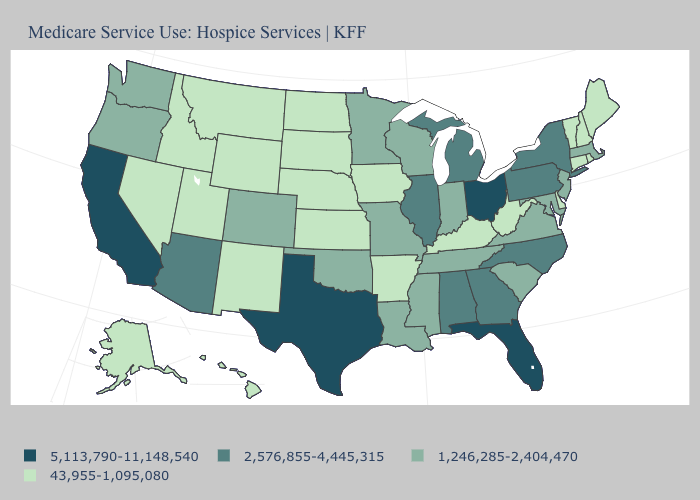Among the states that border Vermont , does New York have the highest value?
Write a very short answer. Yes. Among the states that border Connecticut , which have the highest value?
Give a very brief answer. New York. Name the states that have a value in the range 43,955-1,095,080?
Write a very short answer. Alaska, Arkansas, Connecticut, Delaware, Hawaii, Idaho, Iowa, Kansas, Kentucky, Maine, Montana, Nebraska, Nevada, New Hampshire, New Mexico, North Dakota, Rhode Island, South Dakota, Utah, Vermont, West Virginia, Wyoming. Does the map have missing data?
Write a very short answer. No. How many symbols are there in the legend?
Write a very short answer. 4. What is the highest value in the USA?
Short answer required. 5,113,790-11,148,540. Does New Mexico have the lowest value in the USA?
Answer briefly. Yes. Does Idaho have the lowest value in the West?
Keep it brief. Yes. Name the states that have a value in the range 5,113,790-11,148,540?
Quick response, please. California, Florida, Ohio, Texas. What is the highest value in the South ?
Answer briefly. 5,113,790-11,148,540. Does Kansas have a lower value than Connecticut?
Be succinct. No. What is the value of Pennsylvania?
Write a very short answer. 2,576,855-4,445,315. Name the states that have a value in the range 2,576,855-4,445,315?
Write a very short answer. Alabama, Arizona, Georgia, Illinois, Michigan, New York, North Carolina, Pennsylvania. What is the value of New Jersey?
Concise answer only. 1,246,285-2,404,470. What is the highest value in the MidWest ?
Short answer required. 5,113,790-11,148,540. 